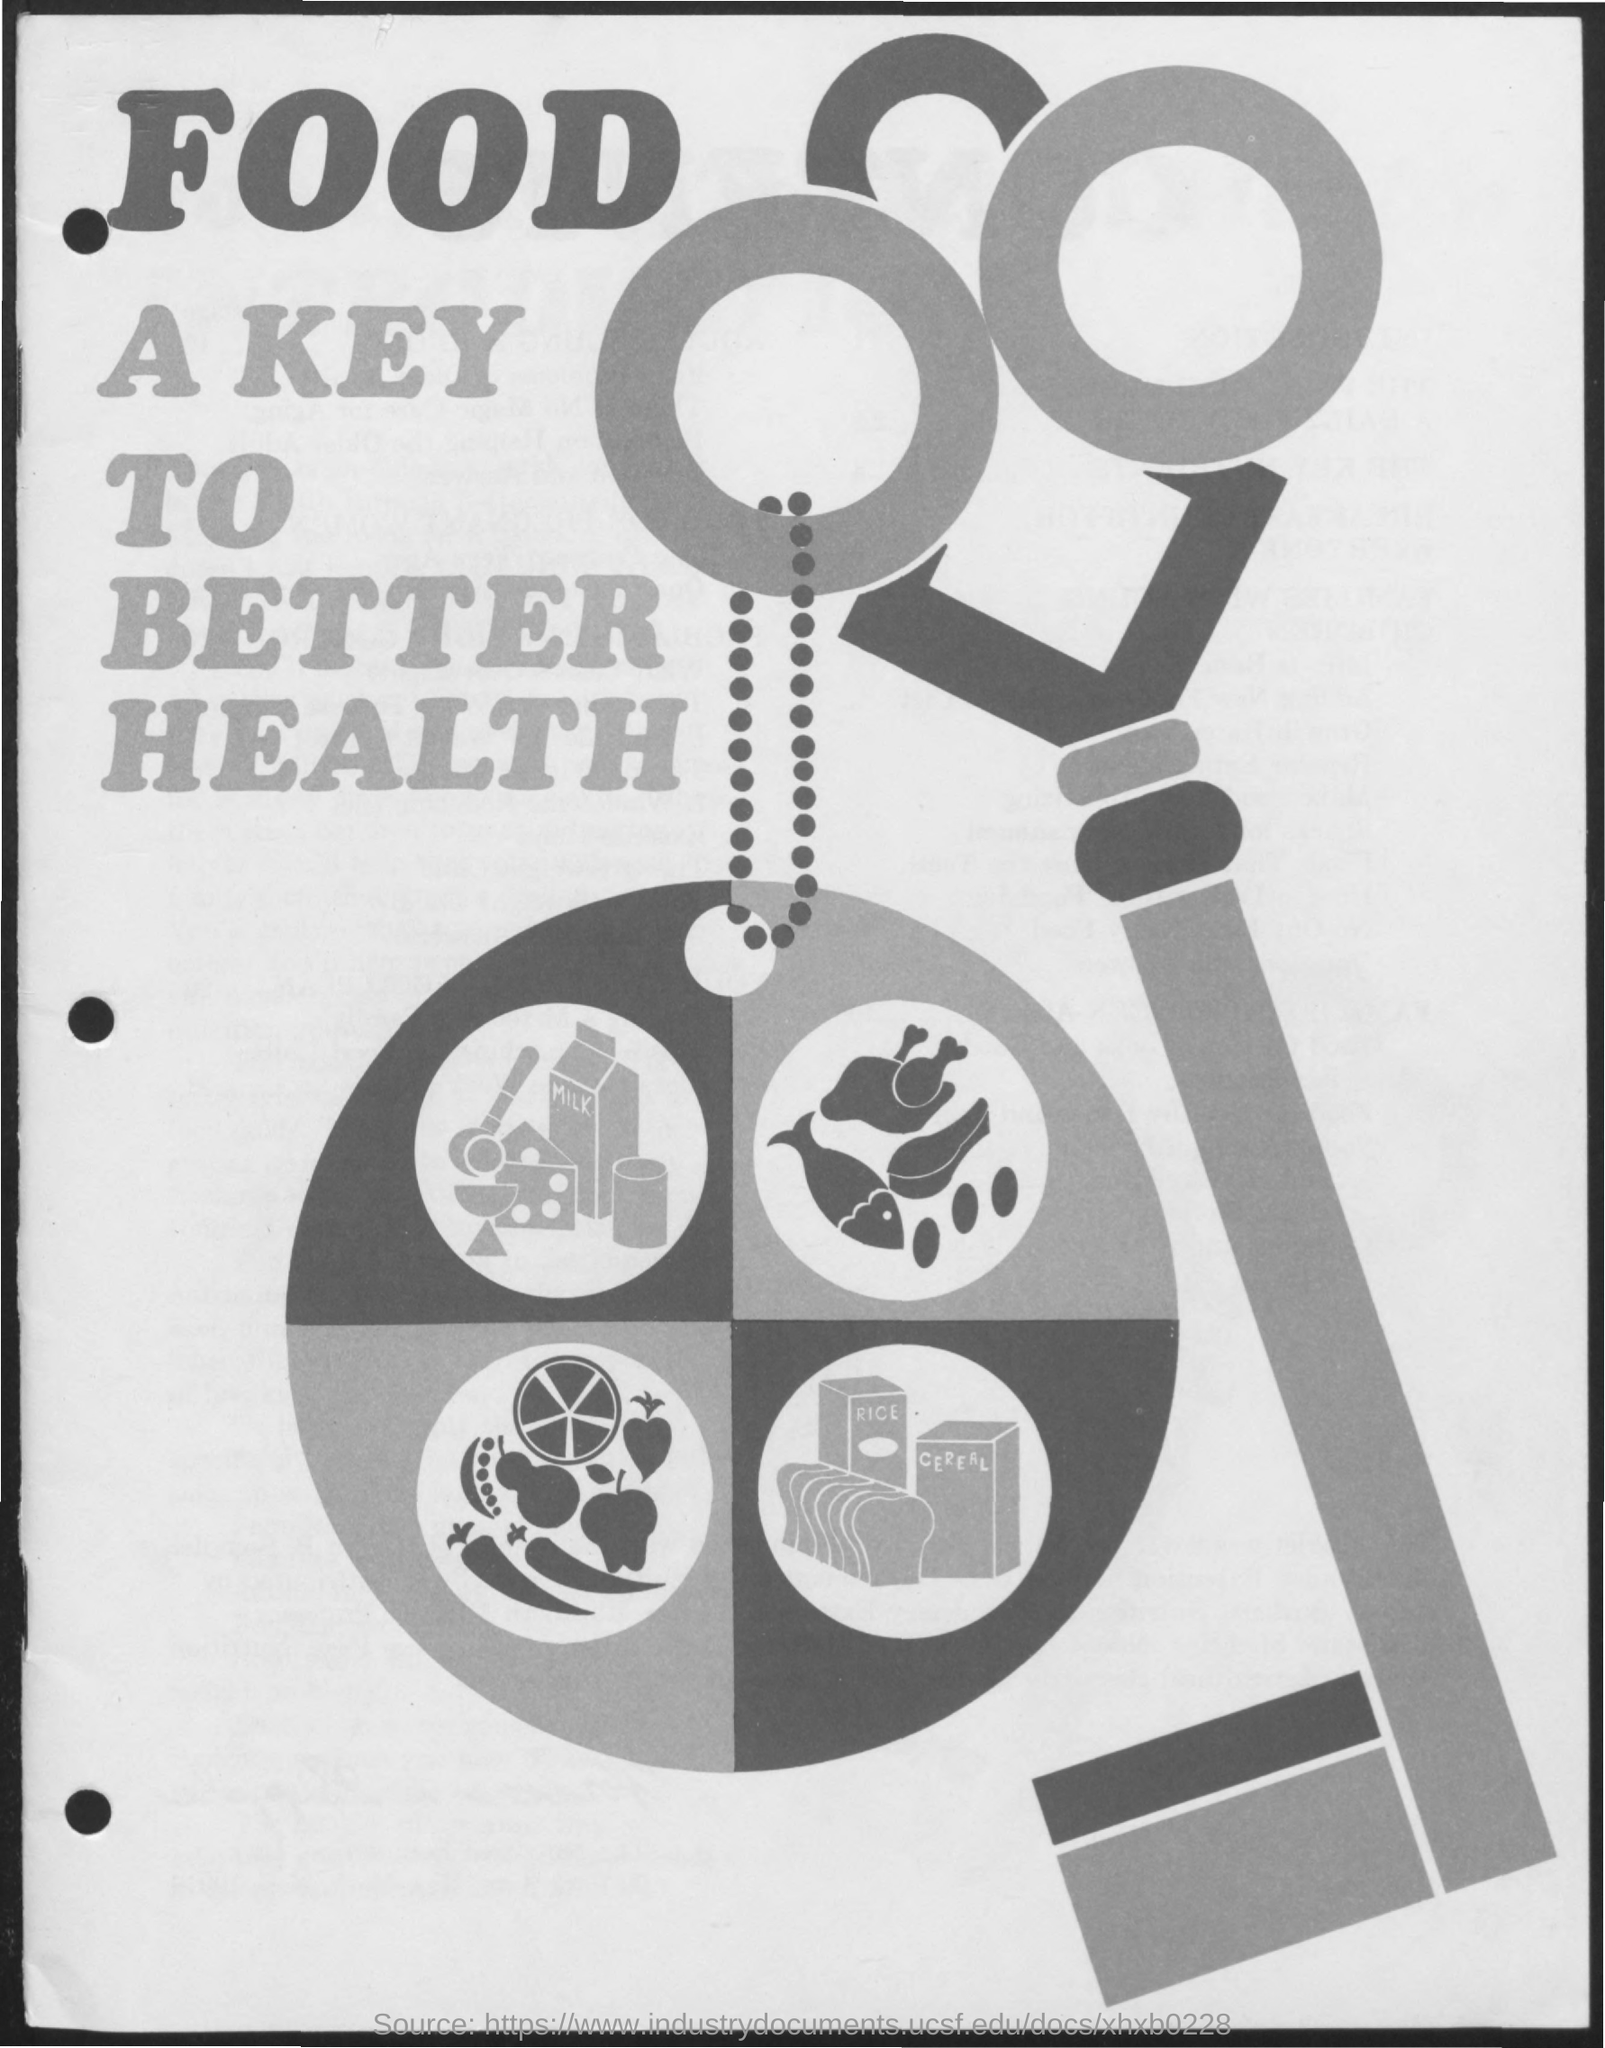List a handful of essential elements in this visual. The document is titled 'Food as the Key to Better Health'. 